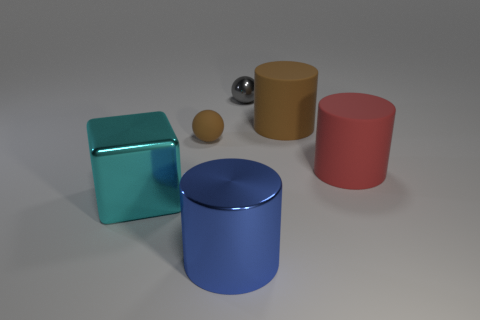Add 3 matte things. How many objects exist? 9 Subtract all blocks. How many objects are left? 5 Subtract 0 blue balls. How many objects are left? 6 Subtract all large red cylinders. Subtract all tiny rubber things. How many objects are left? 4 Add 2 large cubes. How many large cubes are left? 3 Add 4 large cyan shiny cubes. How many large cyan shiny cubes exist? 5 